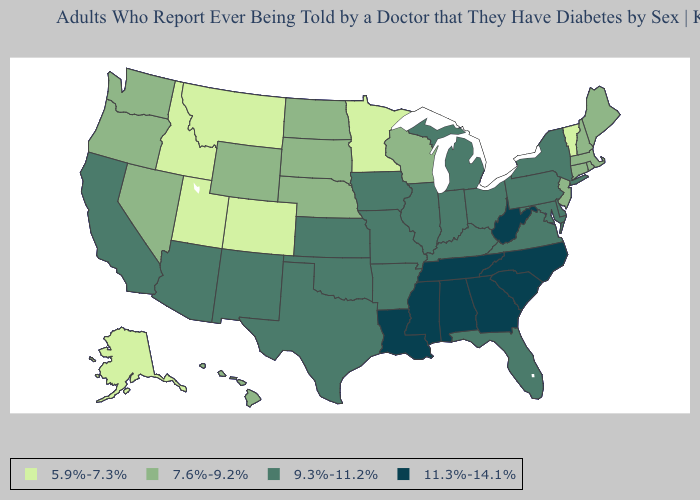Which states hav the highest value in the Northeast?
Keep it brief. New York, Pennsylvania. Does Washington have the same value as Delaware?
Keep it brief. No. What is the value of Missouri?
Short answer required. 9.3%-11.2%. What is the value of Mississippi?
Be succinct. 11.3%-14.1%. What is the highest value in the USA?
Concise answer only. 11.3%-14.1%. What is the highest value in the Northeast ?
Keep it brief. 9.3%-11.2%. Does New Mexico have the highest value in the West?
Keep it brief. Yes. Is the legend a continuous bar?
Concise answer only. No. Name the states that have a value in the range 7.6%-9.2%?
Be succinct. Connecticut, Hawaii, Maine, Massachusetts, Nebraska, Nevada, New Hampshire, New Jersey, North Dakota, Oregon, Rhode Island, South Dakota, Washington, Wisconsin, Wyoming. Name the states that have a value in the range 5.9%-7.3%?
Short answer required. Alaska, Colorado, Idaho, Minnesota, Montana, Utah, Vermont. What is the value of Georgia?
Keep it brief. 11.3%-14.1%. Name the states that have a value in the range 7.6%-9.2%?
Write a very short answer. Connecticut, Hawaii, Maine, Massachusetts, Nebraska, Nevada, New Hampshire, New Jersey, North Dakota, Oregon, Rhode Island, South Dakota, Washington, Wisconsin, Wyoming. Which states have the highest value in the USA?
Write a very short answer. Alabama, Georgia, Louisiana, Mississippi, North Carolina, South Carolina, Tennessee, West Virginia. Does the map have missing data?
Write a very short answer. No. Which states have the lowest value in the USA?
Write a very short answer. Alaska, Colorado, Idaho, Minnesota, Montana, Utah, Vermont. 